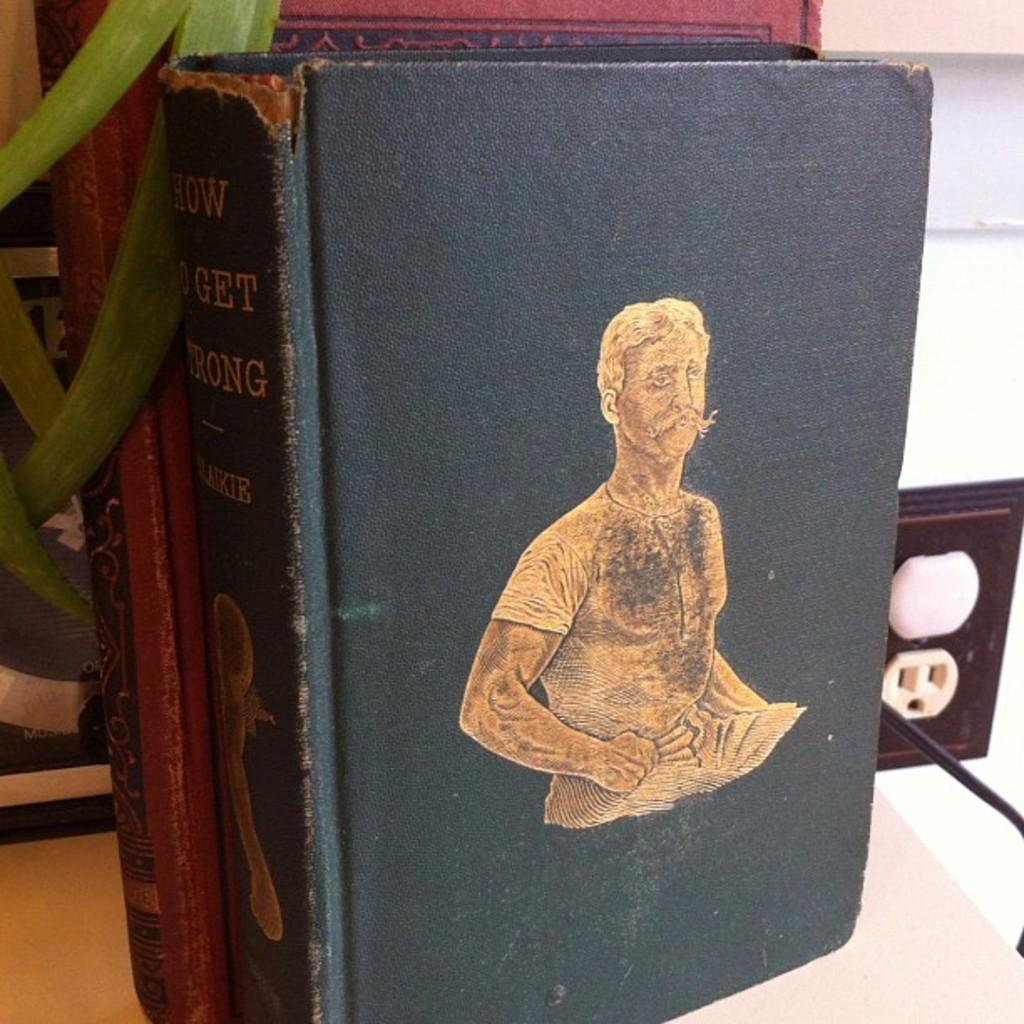<image>
Summarize the visual content of the image. An old, worn book titled How To Get Wrong. 